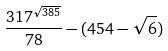Convert formula to latex. <formula><loc_0><loc_0><loc_500><loc_500>\frac { 3 1 7 ^ { \sqrt { 3 8 5 } } } { 7 8 } - ( 4 5 4 - \sqrt { 6 } )</formula> 